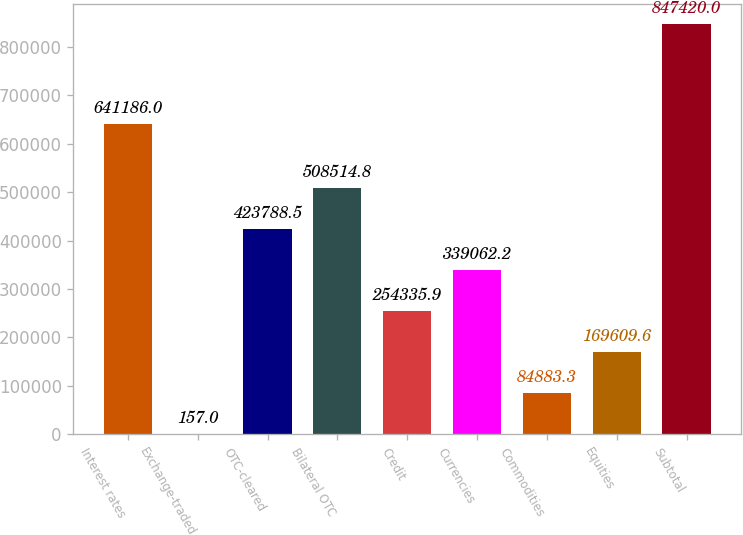<chart> <loc_0><loc_0><loc_500><loc_500><bar_chart><fcel>Interest rates<fcel>Exchange-traded<fcel>OTC-cleared<fcel>Bilateral OTC<fcel>Credit<fcel>Currencies<fcel>Commodities<fcel>Equities<fcel>Subtotal<nl><fcel>641186<fcel>157<fcel>423788<fcel>508515<fcel>254336<fcel>339062<fcel>84883.3<fcel>169610<fcel>847420<nl></chart> 